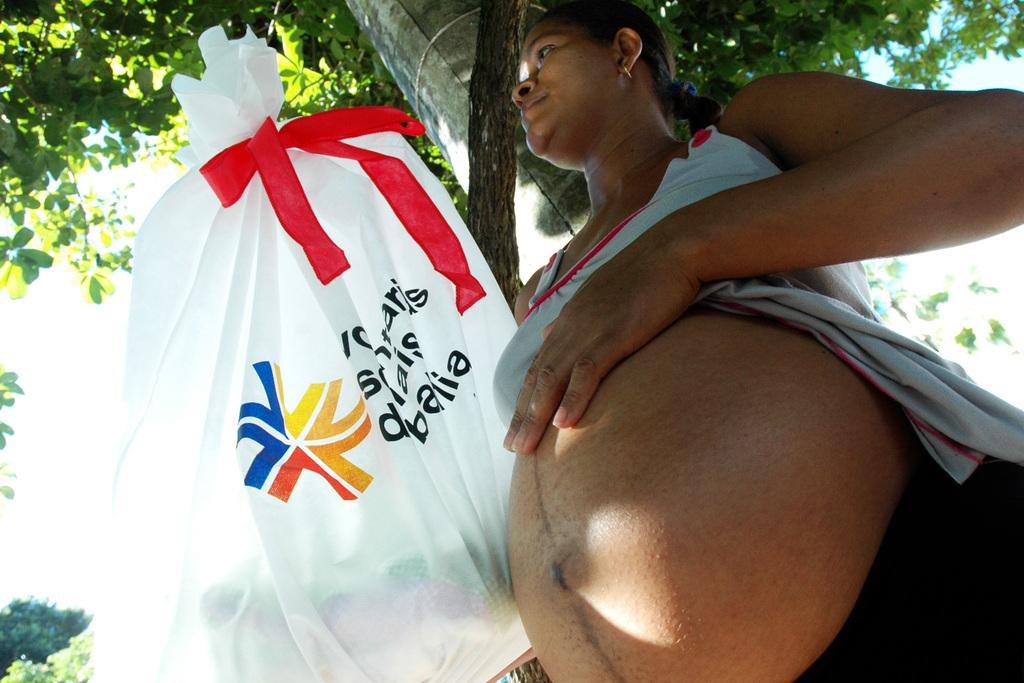What is the main subject of the image? There is a pregnant lady standing in the image. What is hanging from a tree in front of the lady? There is a cover hanging from a tree in front of the lady. What can be seen in the background of the image? There are trees and the sky visible in the background of the image. Is there a cave visible in the image? There is no cave present in the image. Does the existence of the pregnant lady in the image prove the existence of aliens? The presence of a pregnant lady in the image does not prove the existence of aliens, as there is no information or context provided to suggest any connection to extraterrestrial life. 